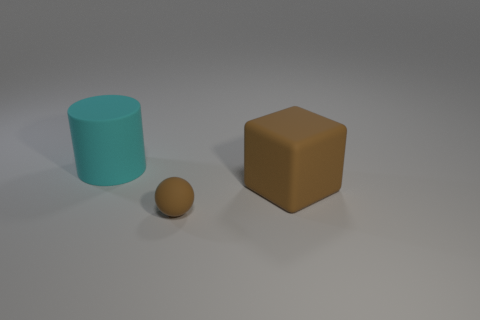Add 1 large brown objects. How many objects exist? 4 Subtract all cubes. How many objects are left? 2 Add 2 brown rubber blocks. How many brown rubber blocks are left? 3 Add 2 big yellow objects. How many big yellow objects exist? 2 Subtract 0 purple balls. How many objects are left? 3 Subtract all small brown balls. Subtract all big red matte objects. How many objects are left? 2 